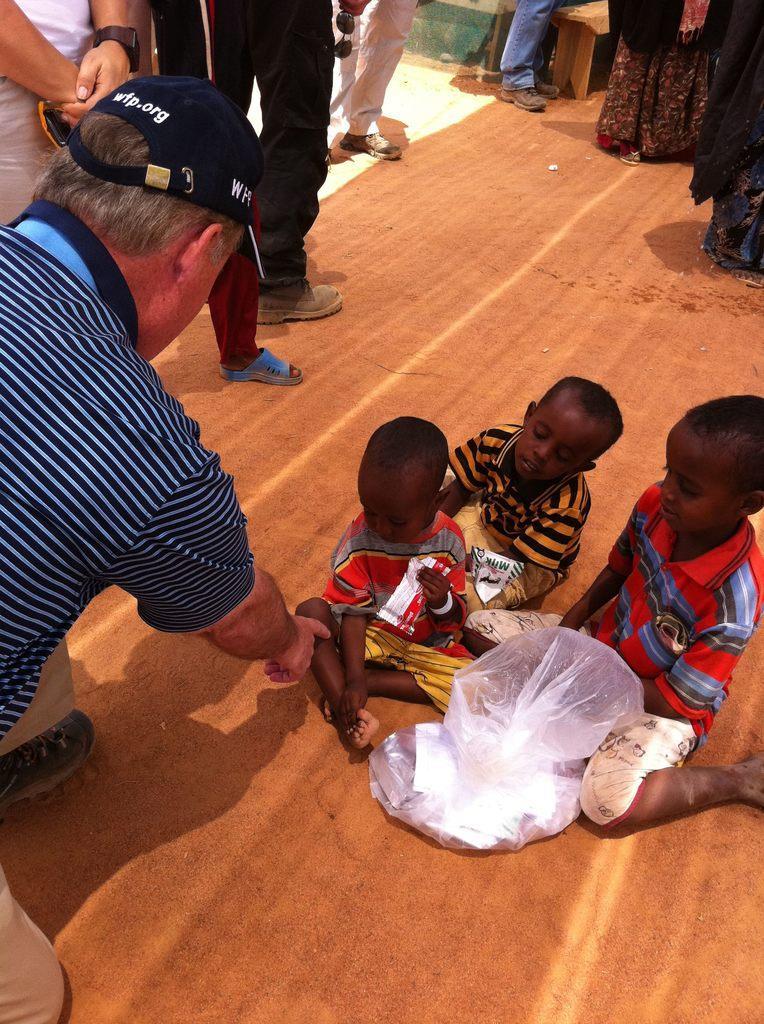Please provide a concise description of this image. In this image we can see people. At the bottom we can see kids sitting and there is a cover placed on the floor. 